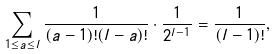<formula> <loc_0><loc_0><loc_500><loc_500>\sum _ { 1 \leq a \leq l } \frac { 1 } { ( a - 1 ) ! ( l - a ) ! } \cdot \frac { 1 } { 2 ^ { l - 1 } } = \frac { 1 } { ( l - 1 ) ! } ,</formula> 